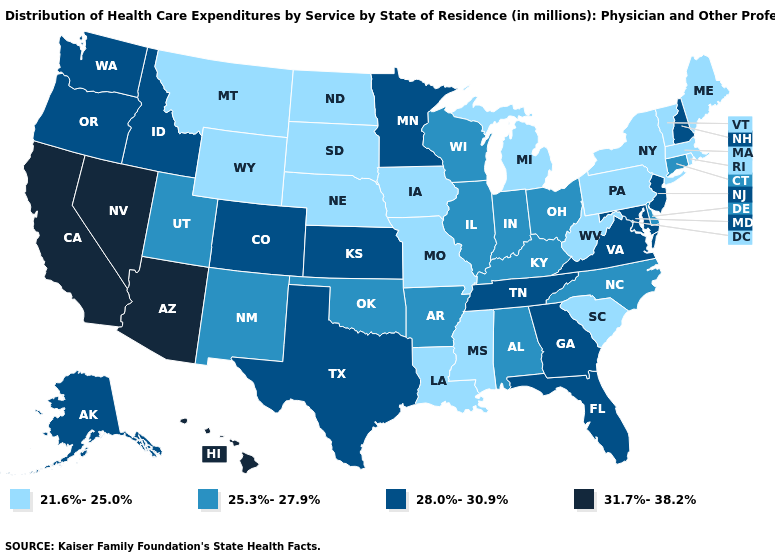Name the states that have a value in the range 25.3%-27.9%?
Write a very short answer. Alabama, Arkansas, Connecticut, Delaware, Illinois, Indiana, Kentucky, New Mexico, North Carolina, Ohio, Oklahoma, Utah, Wisconsin. Which states have the lowest value in the USA?
Quick response, please. Iowa, Louisiana, Maine, Massachusetts, Michigan, Mississippi, Missouri, Montana, Nebraska, New York, North Dakota, Pennsylvania, Rhode Island, South Carolina, South Dakota, Vermont, West Virginia, Wyoming. Does Michigan have the lowest value in the USA?
Short answer required. Yes. Does Alabama have the highest value in the South?
Keep it brief. No. Which states have the lowest value in the USA?
Be succinct. Iowa, Louisiana, Maine, Massachusetts, Michigan, Mississippi, Missouri, Montana, Nebraska, New York, North Dakota, Pennsylvania, Rhode Island, South Carolina, South Dakota, Vermont, West Virginia, Wyoming. Name the states that have a value in the range 21.6%-25.0%?
Quick response, please. Iowa, Louisiana, Maine, Massachusetts, Michigan, Mississippi, Missouri, Montana, Nebraska, New York, North Dakota, Pennsylvania, Rhode Island, South Carolina, South Dakota, Vermont, West Virginia, Wyoming. Name the states that have a value in the range 28.0%-30.9%?
Give a very brief answer. Alaska, Colorado, Florida, Georgia, Idaho, Kansas, Maryland, Minnesota, New Hampshire, New Jersey, Oregon, Tennessee, Texas, Virginia, Washington. Does Washington have the lowest value in the USA?
Keep it brief. No. Name the states that have a value in the range 28.0%-30.9%?
Keep it brief. Alaska, Colorado, Florida, Georgia, Idaho, Kansas, Maryland, Minnesota, New Hampshire, New Jersey, Oregon, Tennessee, Texas, Virginia, Washington. Name the states that have a value in the range 31.7%-38.2%?
Keep it brief. Arizona, California, Hawaii, Nevada. Does New York have the highest value in the USA?
Answer briefly. No. Does Minnesota have a higher value than Texas?
Give a very brief answer. No. Name the states that have a value in the range 31.7%-38.2%?
Concise answer only. Arizona, California, Hawaii, Nevada. Name the states that have a value in the range 21.6%-25.0%?
Write a very short answer. Iowa, Louisiana, Maine, Massachusetts, Michigan, Mississippi, Missouri, Montana, Nebraska, New York, North Dakota, Pennsylvania, Rhode Island, South Carolina, South Dakota, Vermont, West Virginia, Wyoming. Name the states that have a value in the range 25.3%-27.9%?
Give a very brief answer. Alabama, Arkansas, Connecticut, Delaware, Illinois, Indiana, Kentucky, New Mexico, North Carolina, Ohio, Oklahoma, Utah, Wisconsin. 